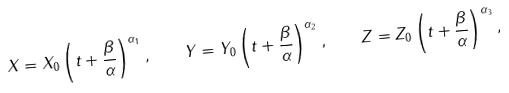Convert formula to latex. <formula><loc_0><loc_0><loc_500><loc_500>X = X _ { 0 } \left ( t + \frac { \beta } { \alpha } \right ) ^ { \alpha _ { 1 } } , \quad Y = Y _ { 0 } \left ( t + \frac { \beta } { \alpha } \right ) ^ { \alpha _ { 2 } } , \quad Z = Z _ { 0 } \left ( t + \frac { \beta } { \alpha } \right ) ^ { \alpha _ { 3 } } ,</formula> 